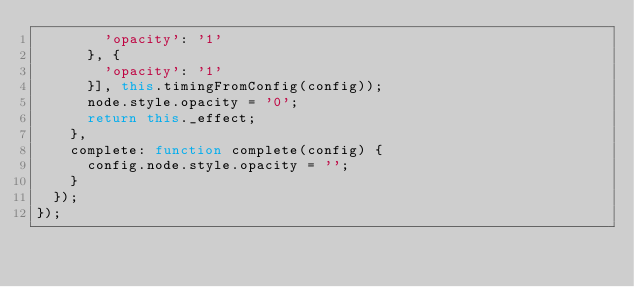<code> <loc_0><loc_0><loc_500><loc_500><_JavaScript_>        'opacity': '1'
      }, {
        'opacity': '1'
      }], this.timingFromConfig(config));
      node.style.opacity = '0';
      return this._effect;
    },
    complete: function complete(config) {
      config.node.style.opacity = '';
    }
  });
});</code> 